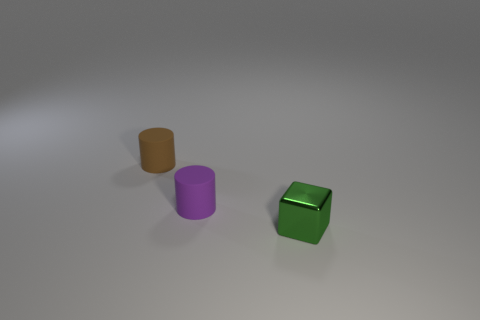What materials do these objects appear to be made of? The objects seem to have a plastic-like appearance with a smooth and reflective surface, suggesting that they could be rendered digitally or made of a synthetic material. 